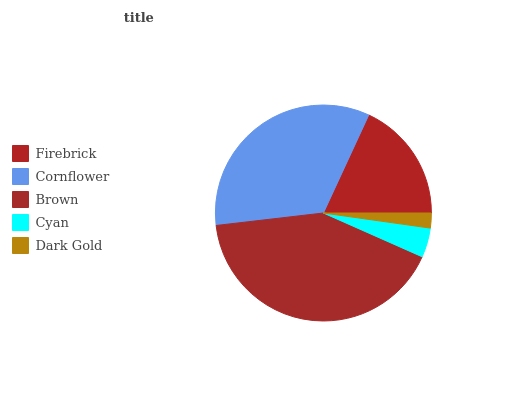Is Dark Gold the minimum?
Answer yes or no. Yes. Is Brown the maximum?
Answer yes or no. Yes. Is Cornflower the minimum?
Answer yes or no. No. Is Cornflower the maximum?
Answer yes or no. No. Is Cornflower greater than Firebrick?
Answer yes or no. Yes. Is Firebrick less than Cornflower?
Answer yes or no. Yes. Is Firebrick greater than Cornflower?
Answer yes or no. No. Is Cornflower less than Firebrick?
Answer yes or no. No. Is Firebrick the high median?
Answer yes or no. Yes. Is Firebrick the low median?
Answer yes or no. Yes. Is Cornflower the high median?
Answer yes or no. No. Is Brown the low median?
Answer yes or no. No. 